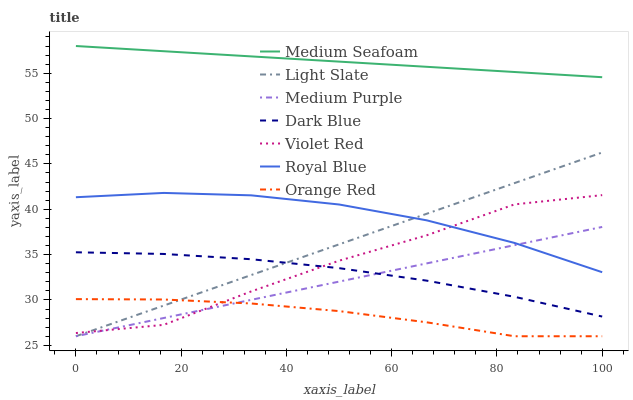Does Orange Red have the minimum area under the curve?
Answer yes or no. Yes. Does Medium Seafoam have the maximum area under the curve?
Answer yes or no. Yes. Does Dark Blue have the minimum area under the curve?
Answer yes or no. No. Does Dark Blue have the maximum area under the curve?
Answer yes or no. No. Is Medium Purple the smoothest?
Answer yes or no. Yes. Is Violet Red the roughest?
Answer yes or no. Yes. Is Dark Blue the smoothest?
Answer yes or no. No. Is Dark Blue the roughest?
Answer yes or no. No. Does Dark Blue have the lowest value?
Answer yes or no. No. Does Medium Seafoam have the highest value?
Answer yes or no. Yes. Does Dark Blue have the highest value?
Answer yes or no. No. Is Orange Red less than Royal Blue?
Answer yes or no. Yes. Is Royal Blue greater than Orange Red?
Answer yes or no. Yes. Does Dark Blue intersect Medium Purple?
Answer yes or no. Yes. Is Dark Blue less than Medium Purple?
Answer yes or no. No. Is Dark Blue greater than Medium Purple?
Answer yes or no. No. Does Orange Red intersect Royal Blue?
Answer yes or no. No. 